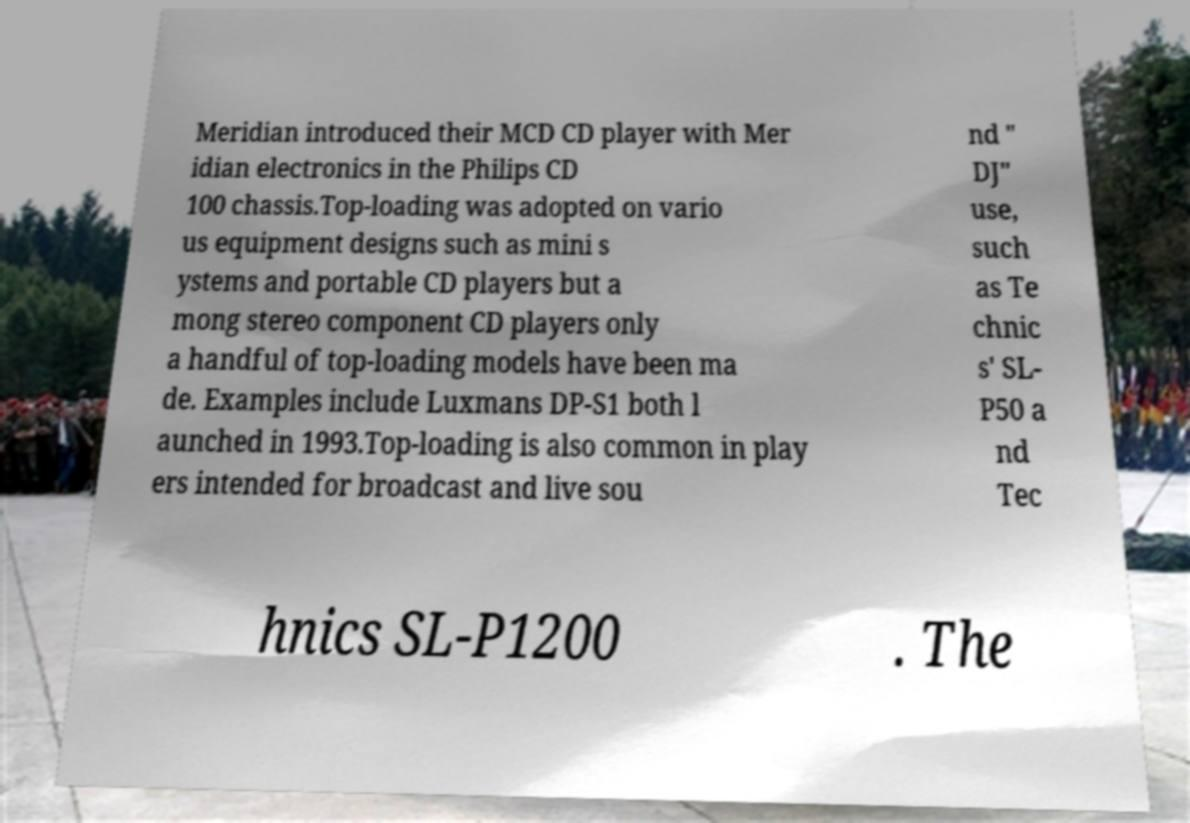Please read and relay the text visible in this image. What does it say? Meridian introduced their MCD CD player with Mer idian electronics in the Philips CD 100 chassis.Top-loading was adopted on vario us equipment designs such as mini s ystems and portable CD players but a mong stereo component CD players only a handful of top-loading models have been ma de. Examples include Luxmans DP-S1 both l aunched in 1993.Top-loading is also common in play ers intended for broadcast and live sou nd " DJ" use, such as Te chnic s' SL- P50 a nd Tec hnics SL-P1200 . The 